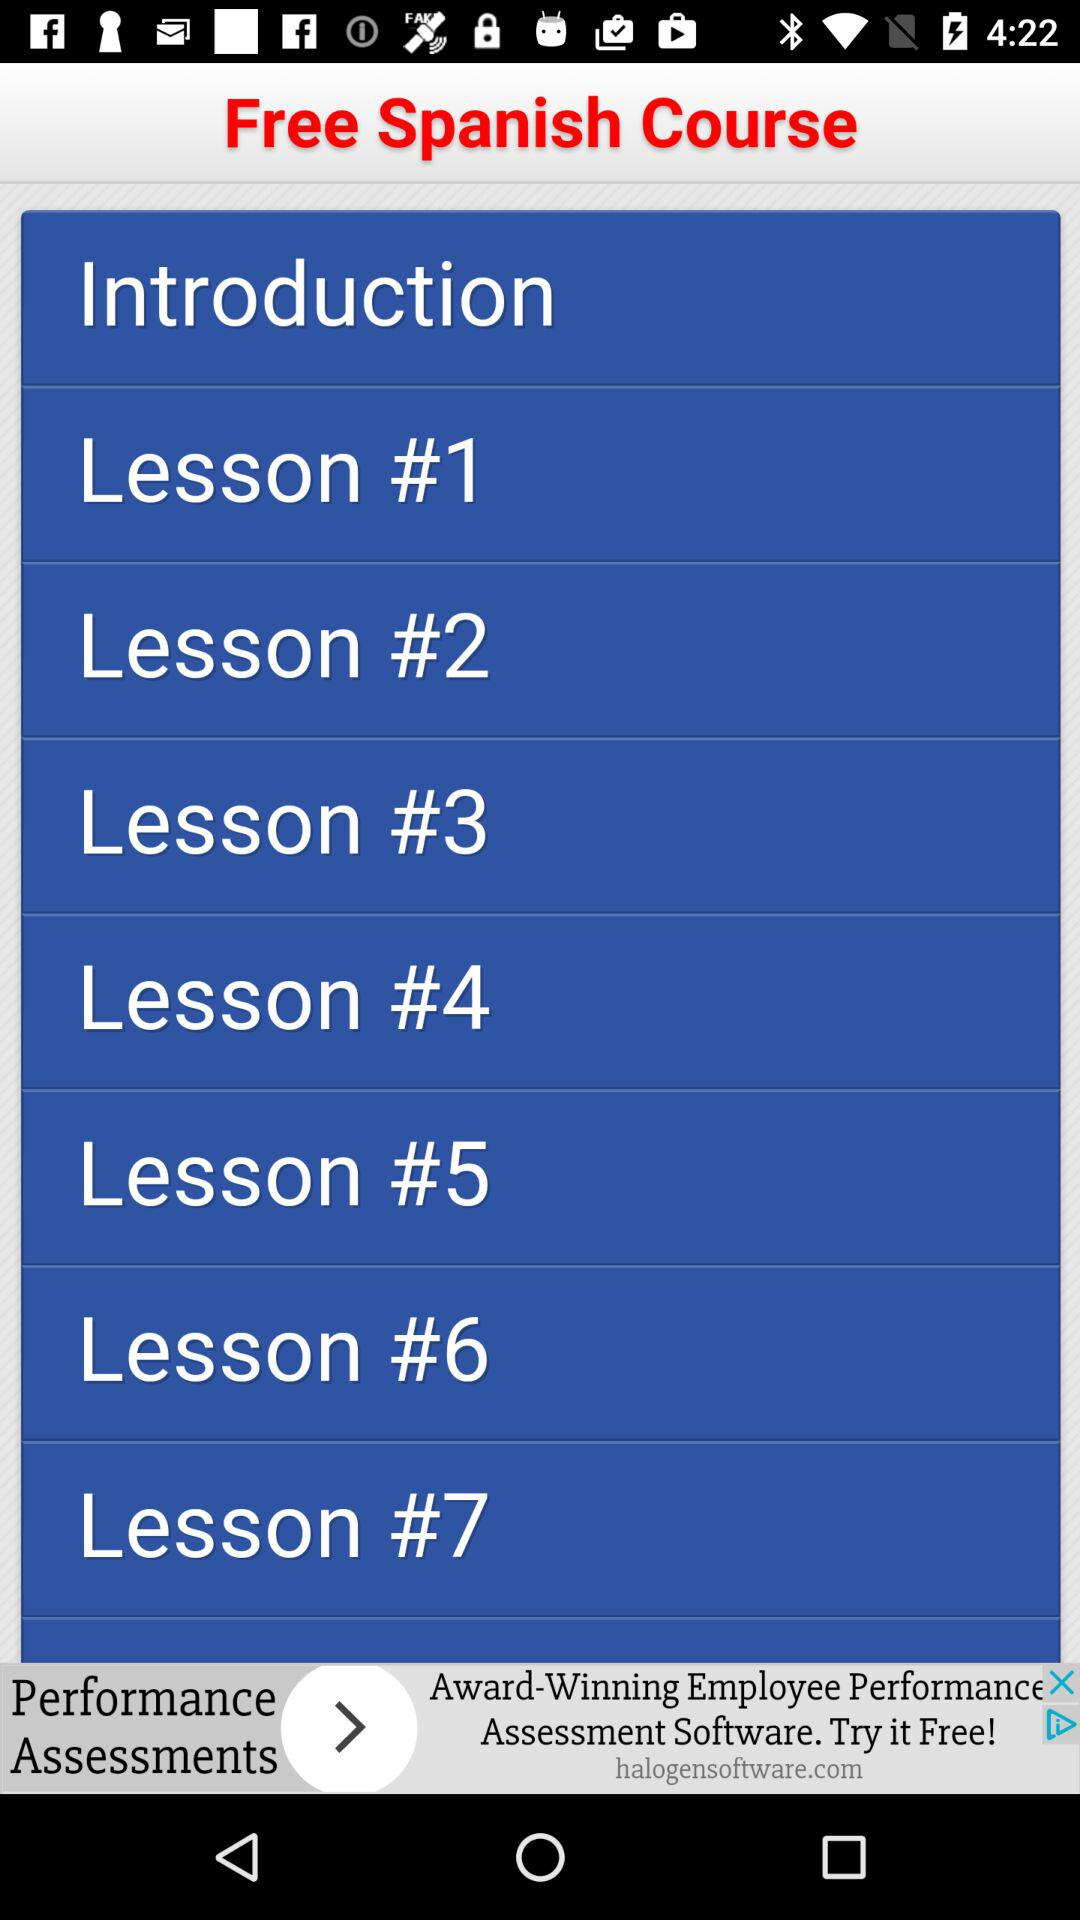How many lessons are there in the Free Spanish Course?
Answer the question using a single word or phrase. 7 